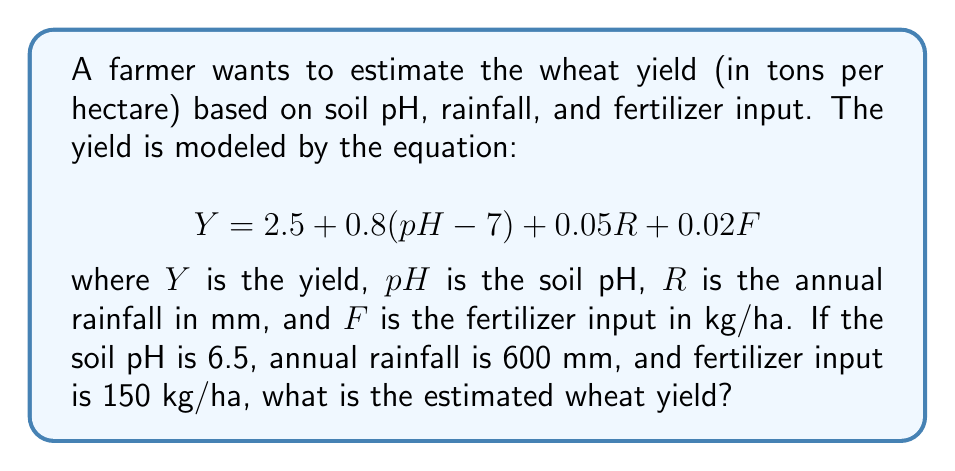Could you help me with this problem? Let's solve this problem step by step:

1) We are given the equation:
   $$Y = 2.5 + 0.8(pH - 7) + 0.05R + 0.02F$$

2) We know the following values:
   $pH = 6.5$
   $R = 600$ mm
   $F = 150$ kg/ha

3) Let's substitute these values into the equation:
   $$Y = 2.5 + 0.8(6.5 - 7) + 0.05(600) + 0.02(150)$$

4) First, let's calculate $(pH - 7)$:
   $6.5 - 7 = -0.5$

5) Now, our equation looks like this:
   $$Y = 2.5 + 0.8(-0.5) + 0.05(600) + 0.02(150)$$

6) Let's solve each part:
   $0.8(-0.5) = -0.4$
   $0.05(600) = 30$
   $0.02(150) = 3$

7) Now we can add all parts:
   $$Y = 2.5 + (-0.4) + 30 + 3$$

8) Finally, let's sum up:
   $$Y = 35.1$$

Therefore, the estimated wheat yield is 35.1 tons per hectare.
Answer: 35.1 tons/ha 